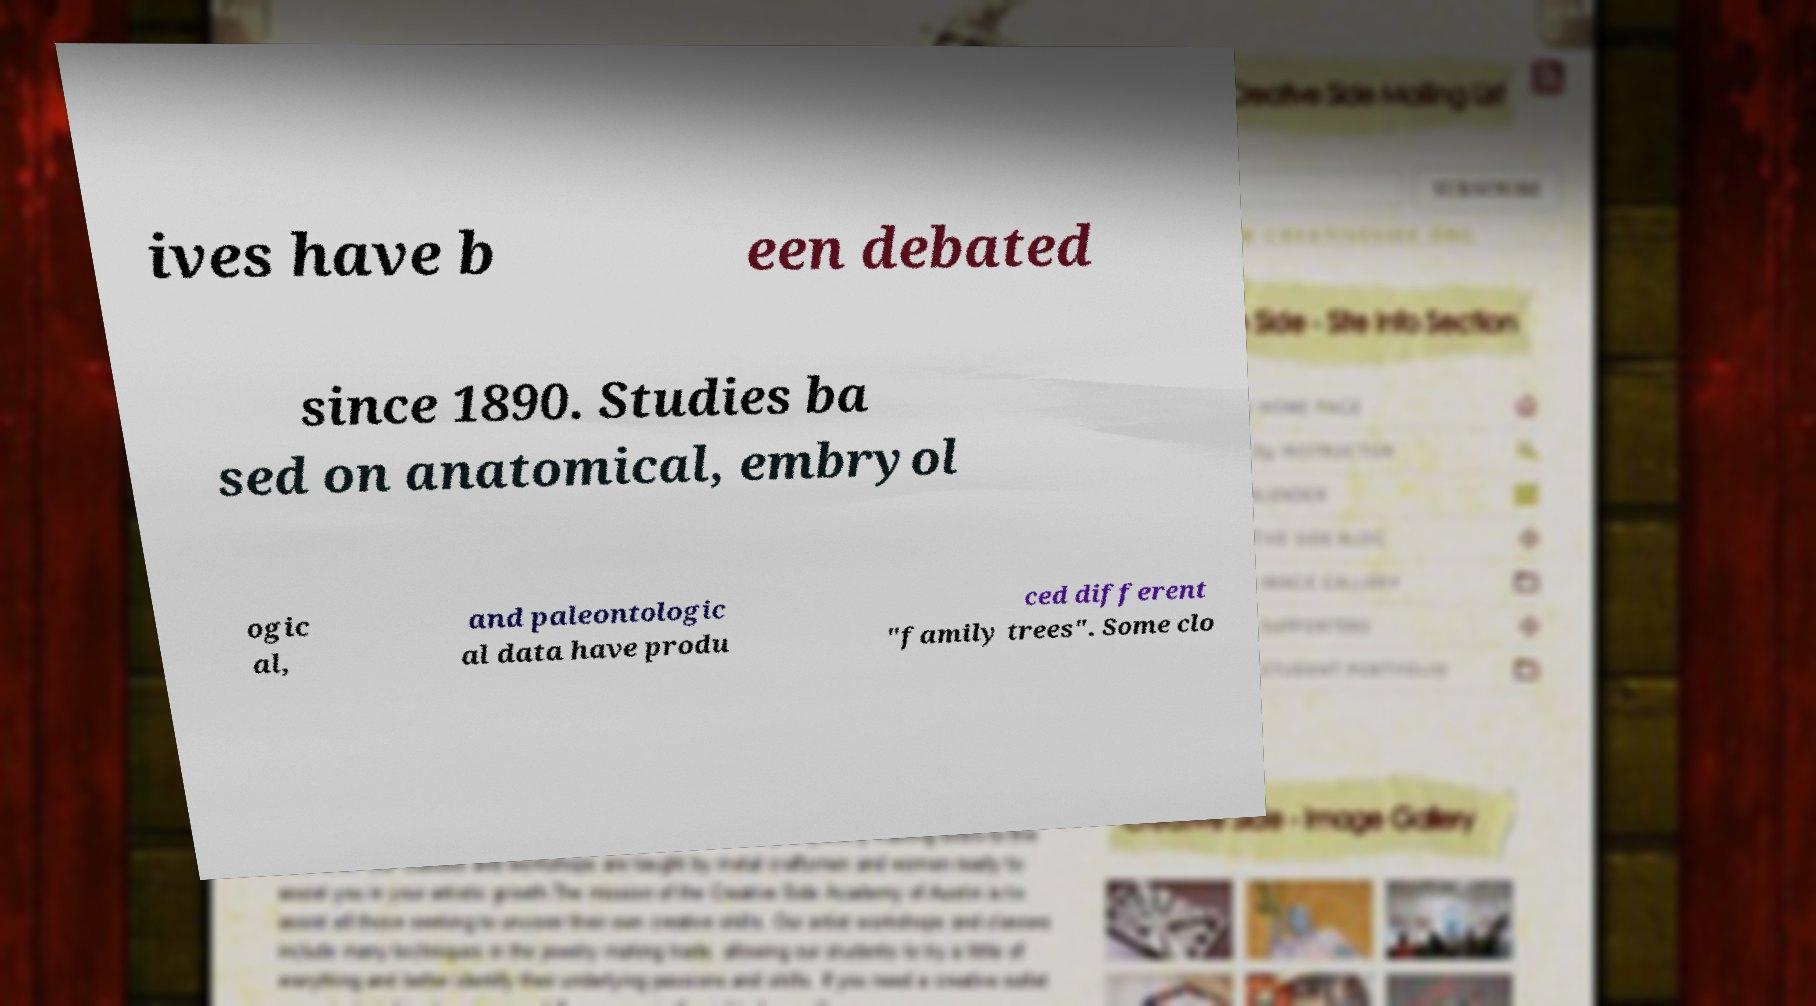What messages or text are displayed in this image? I need them in a readable, typed format. ives have b een debated since 1890. Studies ba sed on anatomical, embryol ogic al, and paleontologic al data have produ ced different "family trees". Some clo 